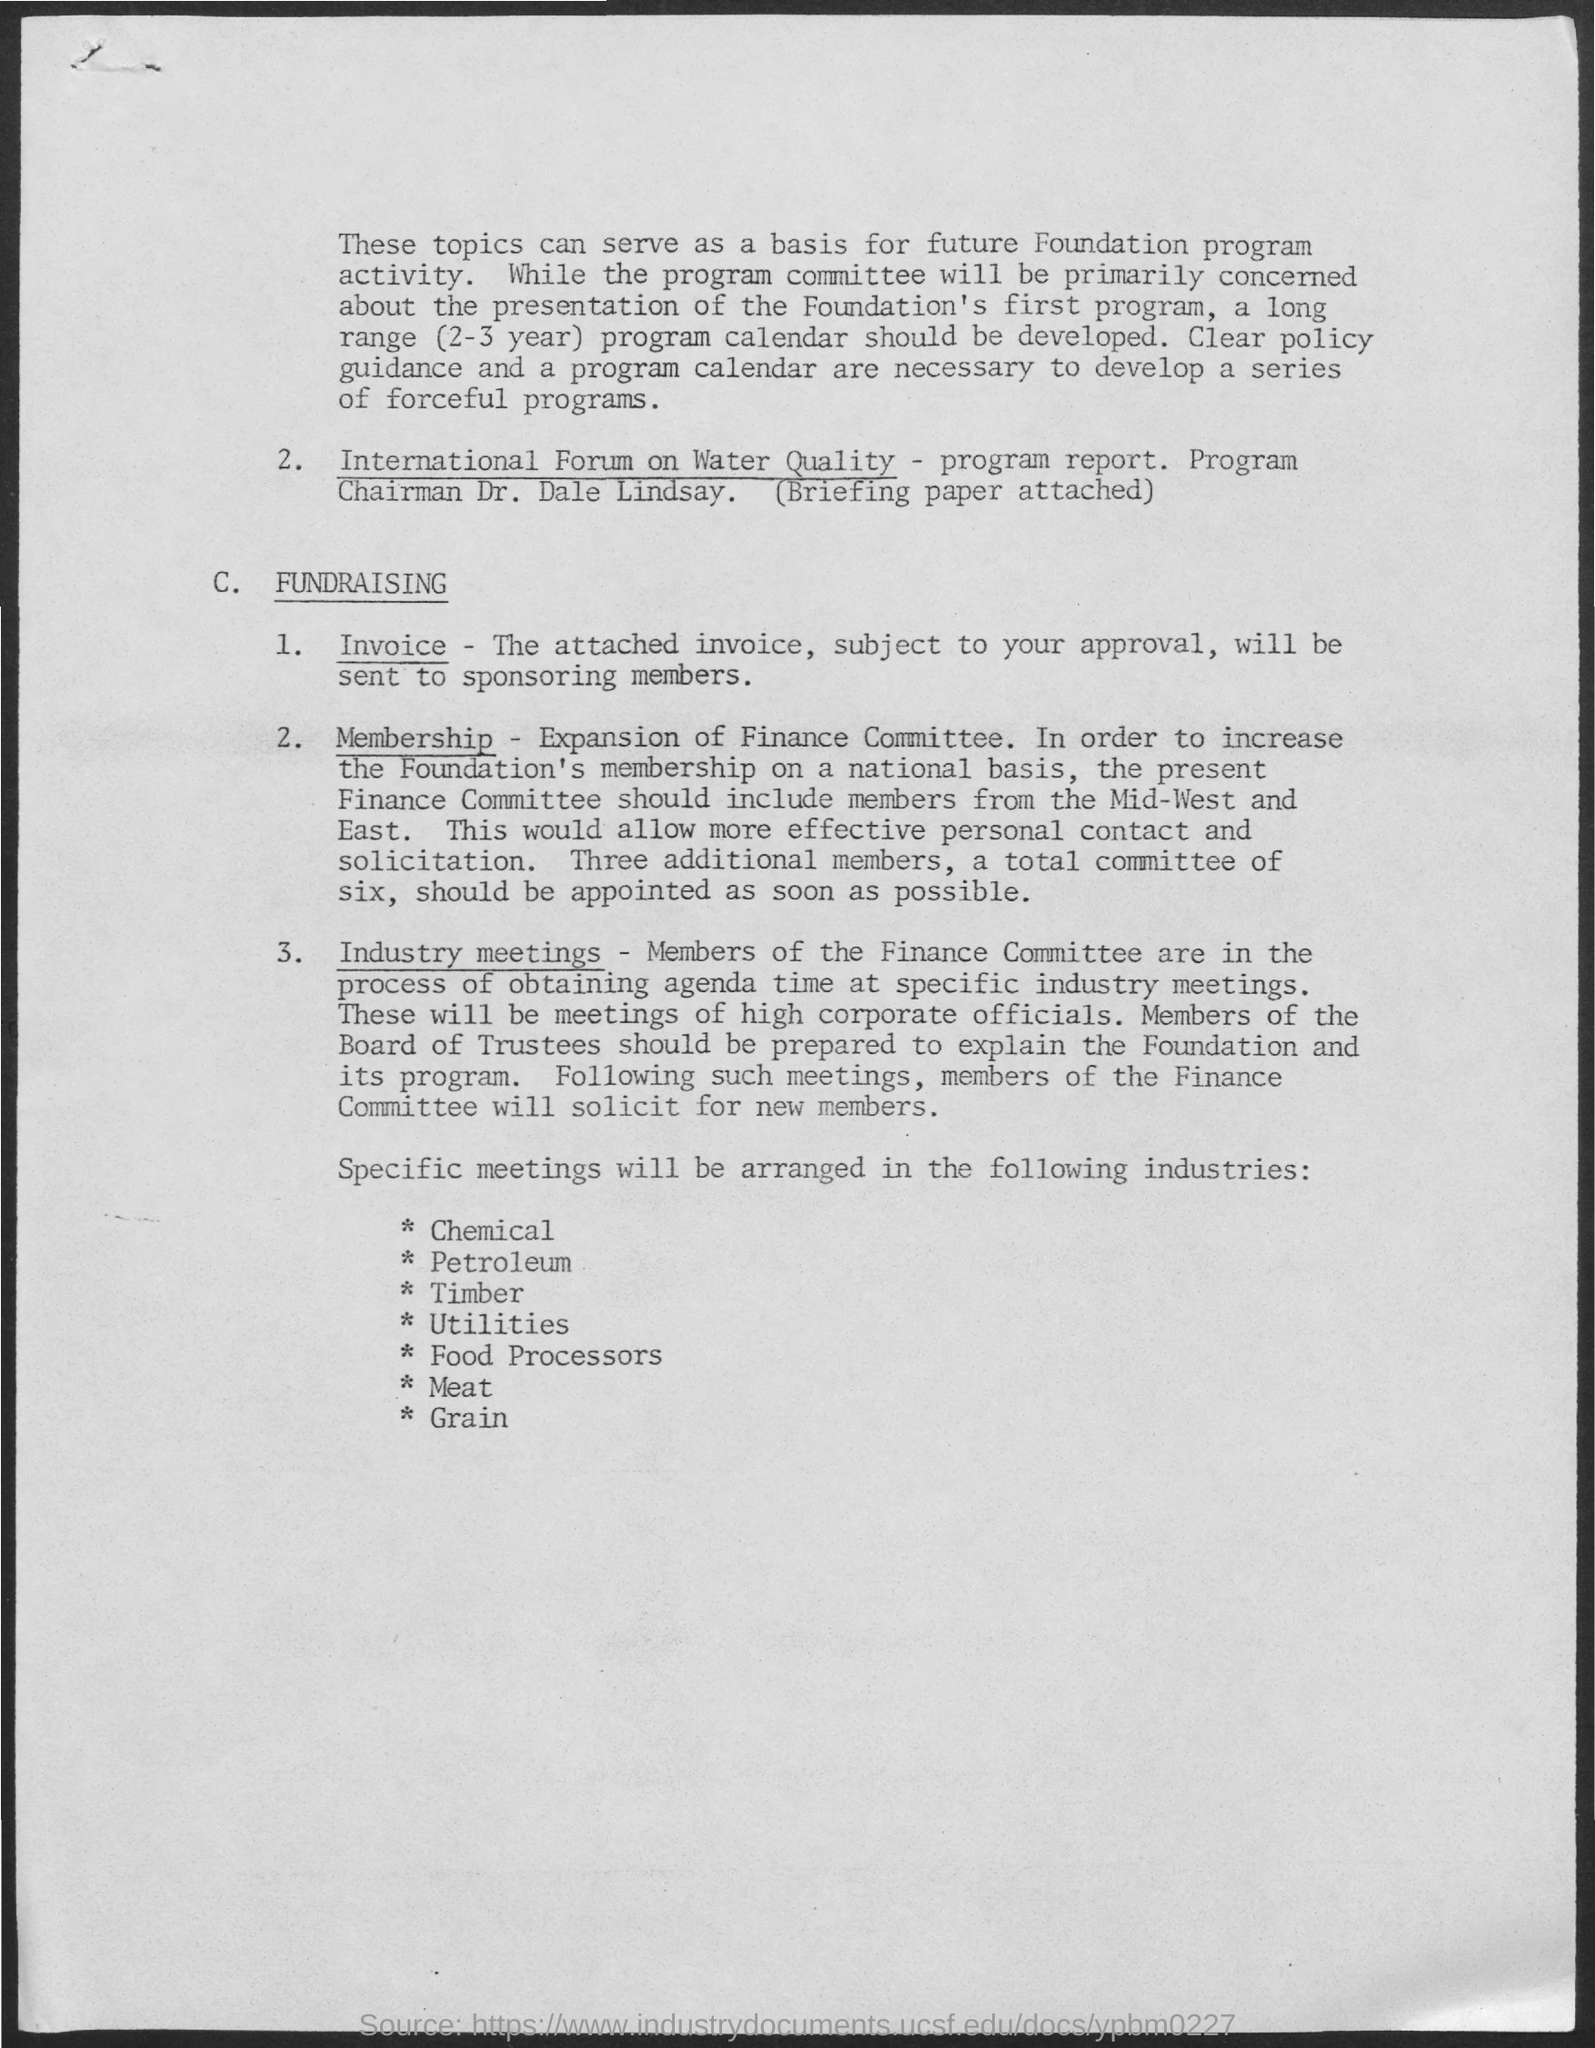To where the approved invoice sent to?
Your answer should be compact. SPONSORING MEMBERS. 